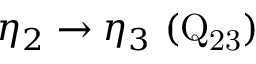<formula> <loc_0><loc_0><loc_500><loc_500>\eta _ { 2 } \rightarrow \eta _ { 3 } ( Q _ { 2 3 } )</formula> 